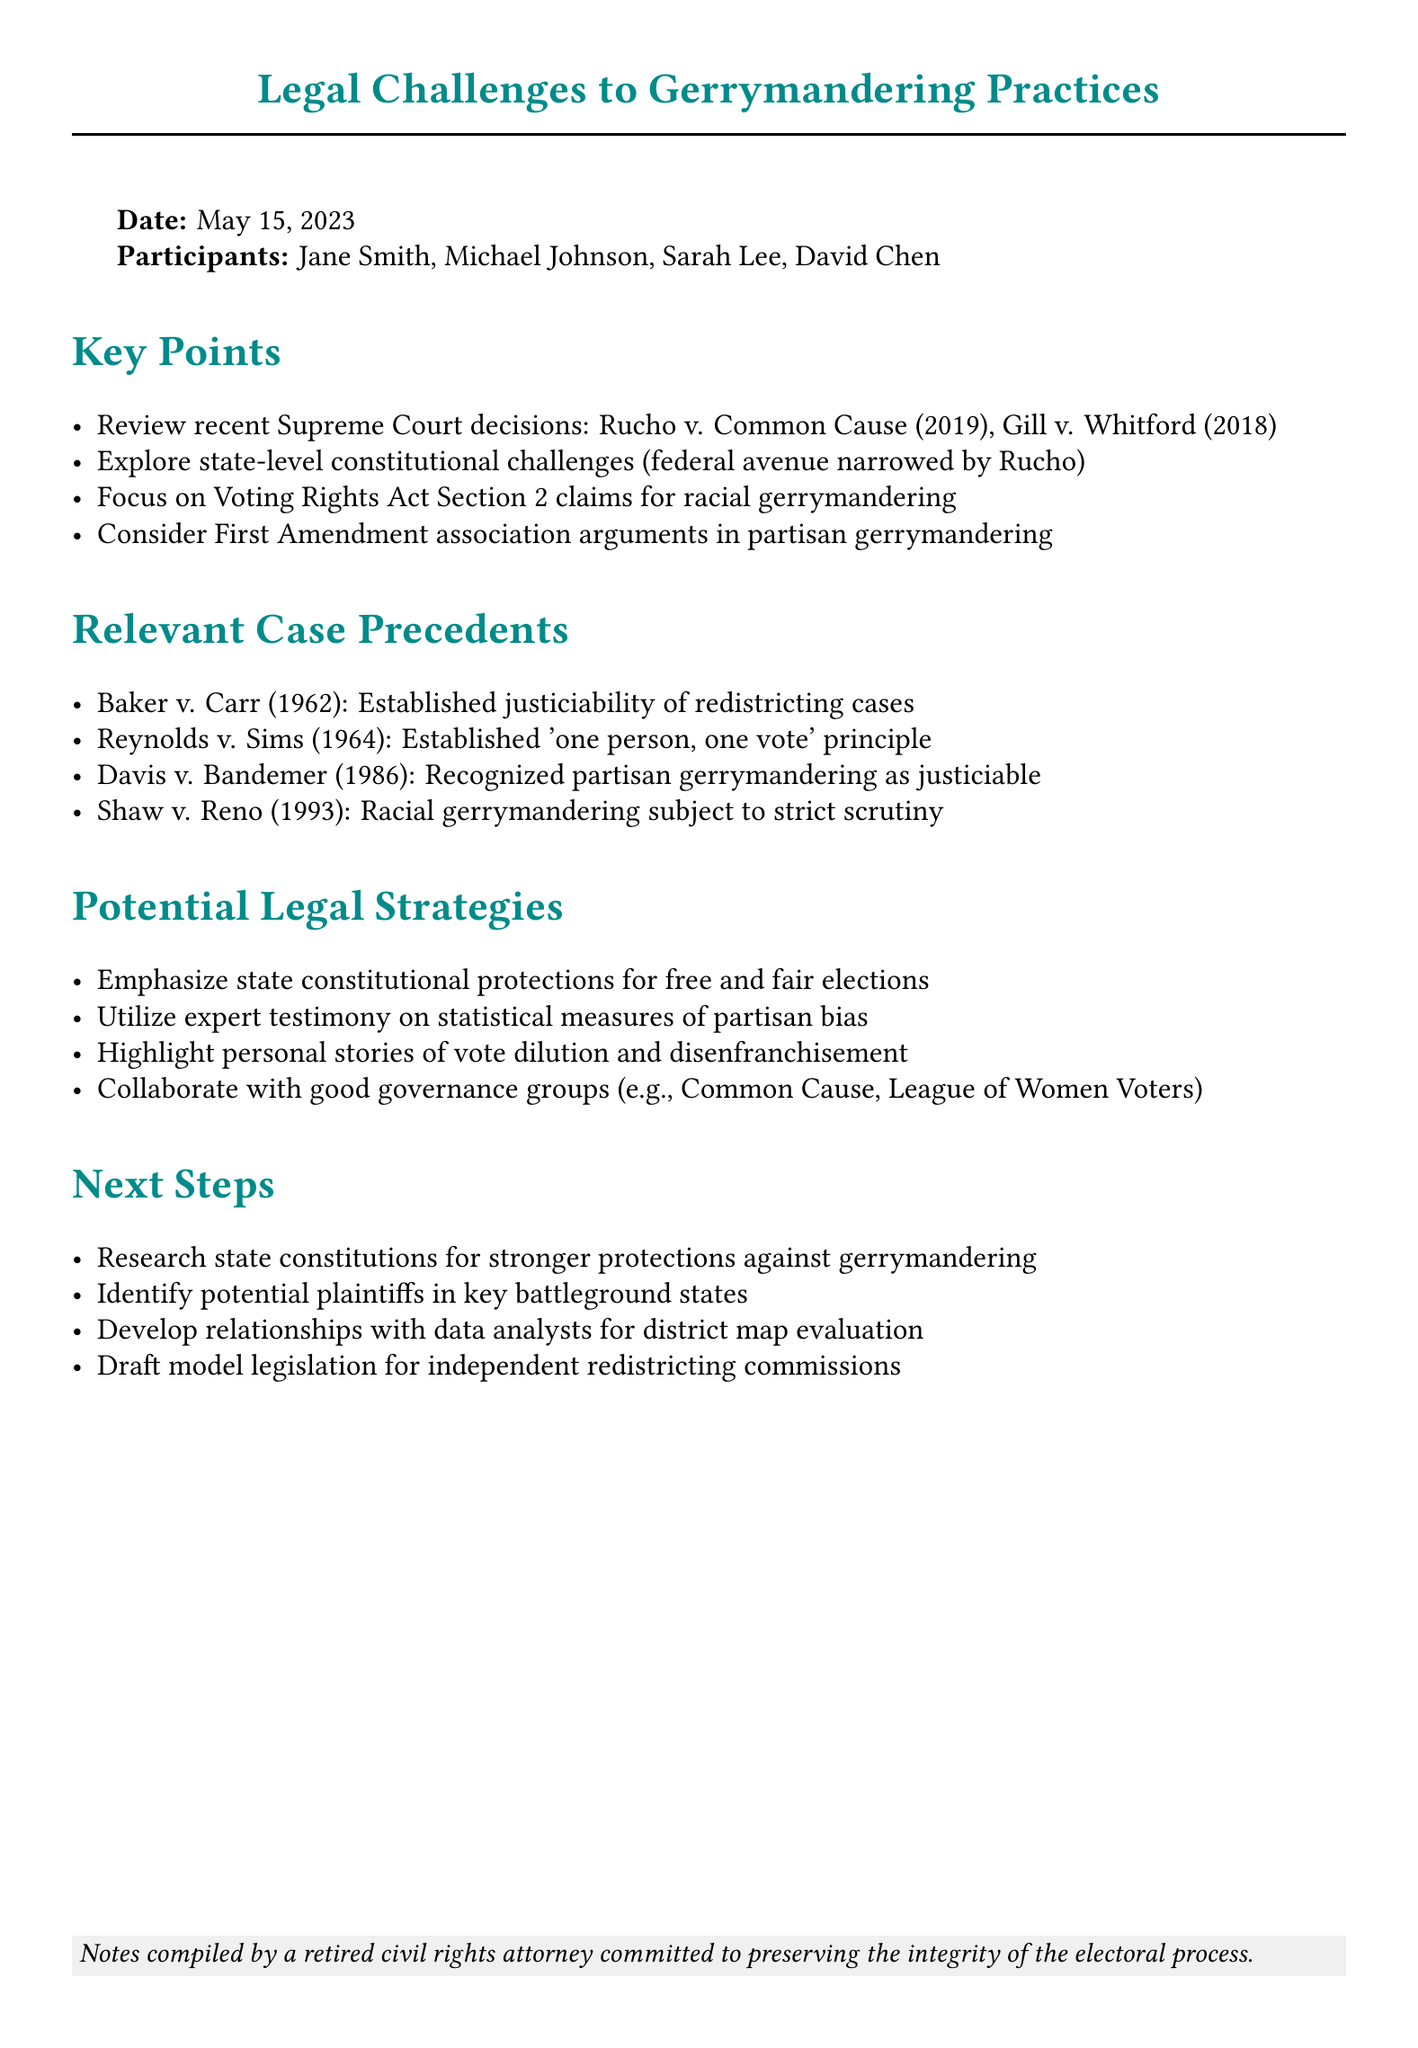What is the date of the brainstorming session? The date is explicitly mentioned in the document as May 15, 2023.
Answer: May 15, 2023 Who participated in the session alongside Jane Smith? The document lists the participants including Michael Johnson, Sarah Lee, and David Chen.
Answer: Michael Johnson, Sarah Lee, David Chen Which Supreme Court decision narrowed the federal avenue for challenges? The document cites the Rucho v. Common Cause decision as having this effect.
Answer: Rucho v. Common Cause What legal strategy emphasizes state constitutional protections? This strategy is directly mentioned in the section on Potential Legal Strategies within the notes.
Answer: Emphasize state constitutional protections for free and fair elections Which case established the 'one person, one vote' principle? The document lists Reynolds v. Sims as the precedent that established this principle.
Answer: Reynolds v. Sims Which section of the Voting Rights Act focuses on racial gerrymandering claims? The document specifies Voting Rights Act Section 2 as relevant for these claims.
Answer: Section 2 What is one next step mentioned regarding plaintiffs? The notes outline a specific action regarding identifying potential plaintiffs in battleground states.
Answer: Identify potential plaintiffs in key battleground states Who collaborated with the group mentioned in potential legal strategies? The document suggests collaboration with good governance groups like Common Cause and League of Women Voters.
Answer: Common Cause and League of Women Voters What was a key point concerning partisan gerrymandering challenges? The document discusses First Amendment association arguments as a key point related to these challenges.
Answer: First Amendment association arguments 